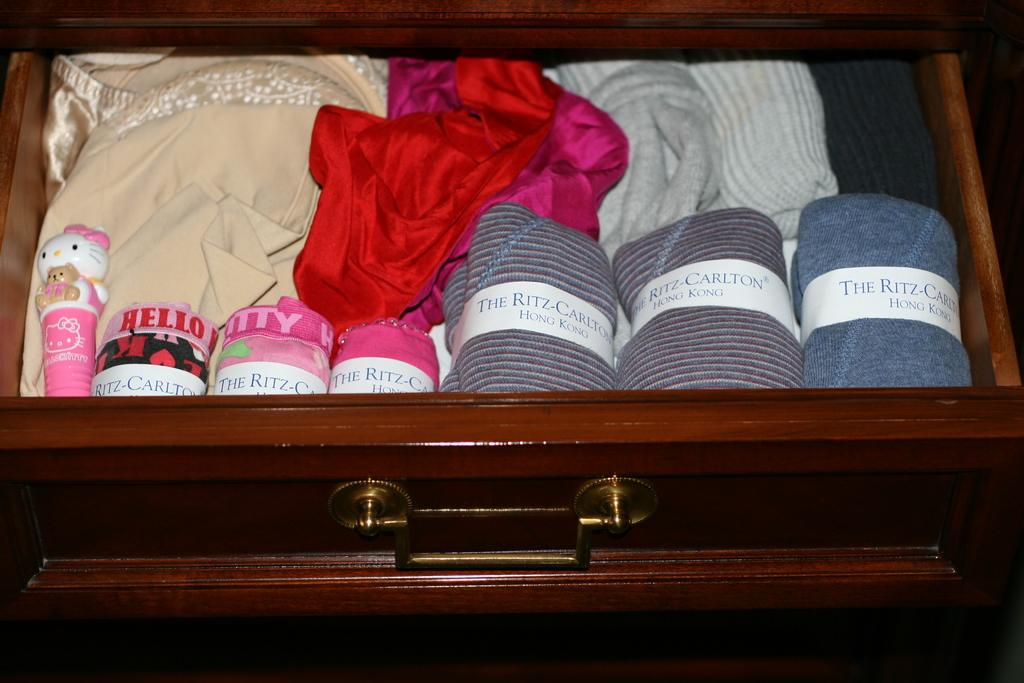<image>
Summarize the visual content of the image. Dresser that contains The Ritz Carlton in Hong Kong 